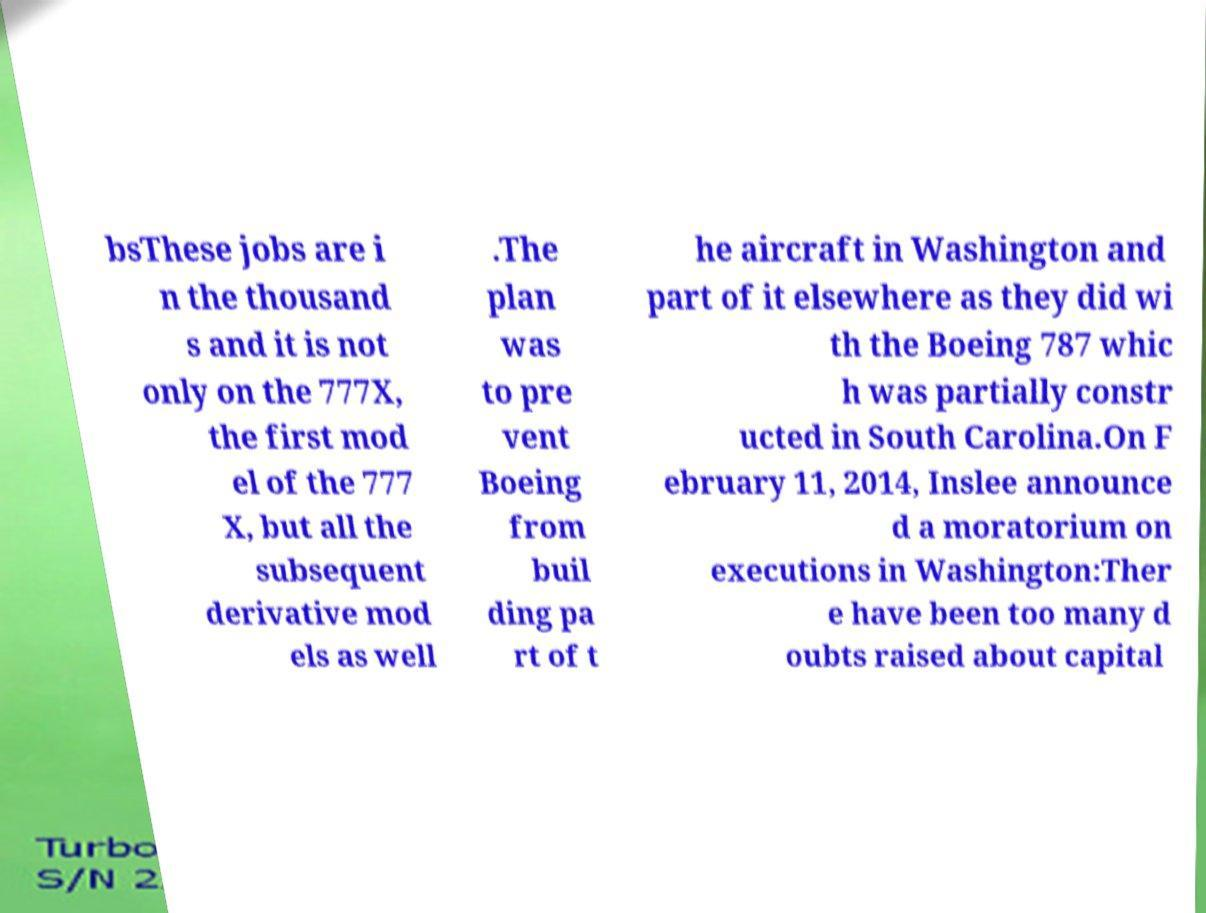What messages or text are displayed in this image? I need them in a readable, typed format. bsThese jobs are i n the thousand s and it is not only on the 777X, the first mod el of the 777 X, but all the subsequent derivative mod els as well .The plan was to pre vent Boeing from buil ding pa rt of t he aircraft in Washington and part of it elsewhere as they did wi th the Boeing 787 whic h was partially constr ucted in South Carolina.On F ebruary 11, 2014, Inslee announce d a moratorium on executions in Washington:Ther e have been too many d oubts raised about capital 